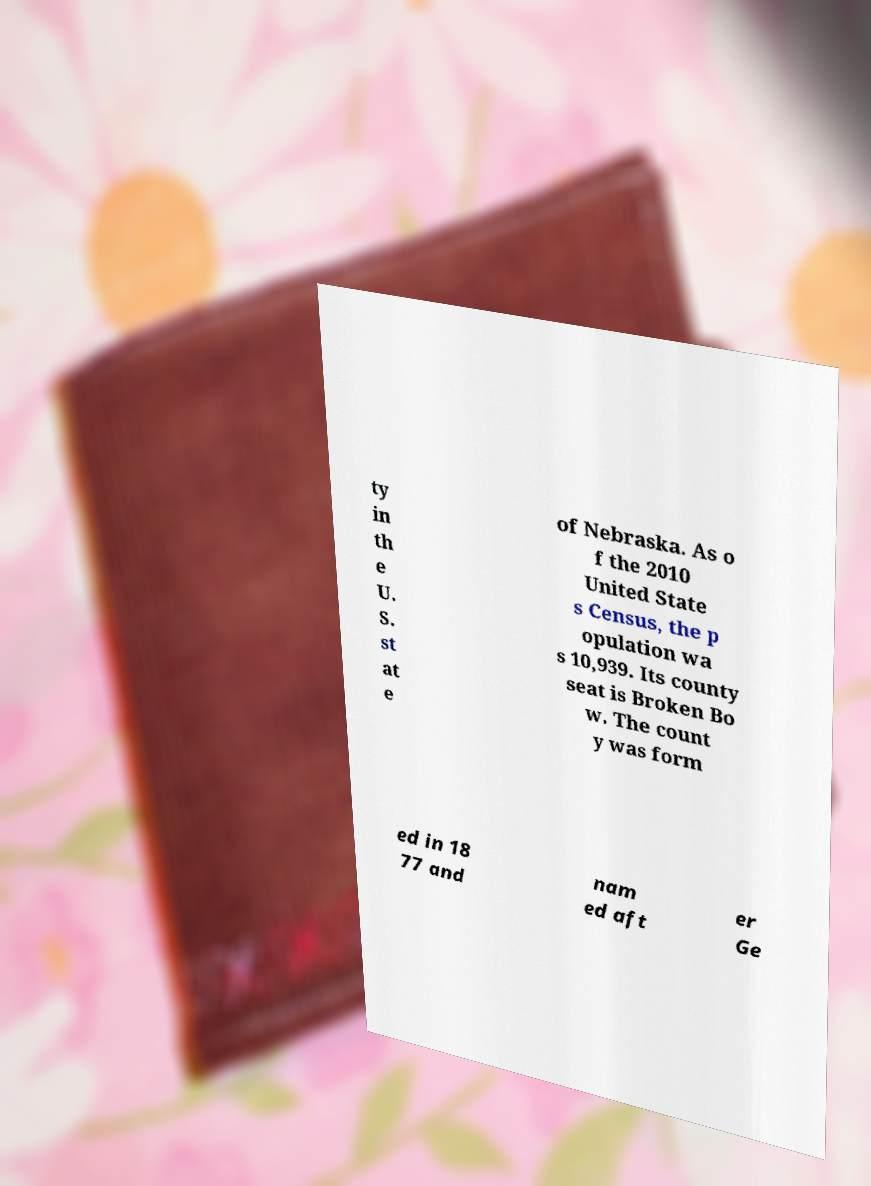Can you accurately transcribe the text from the provided image for me? ty in th e U. S. st at e of Nebraska. As o f the 2010 United State s Census, the p opulation wa s 10,939. Its county seat is Broken Bo w. The count y was form ed in 18 77 and nam ed aft er Ge 